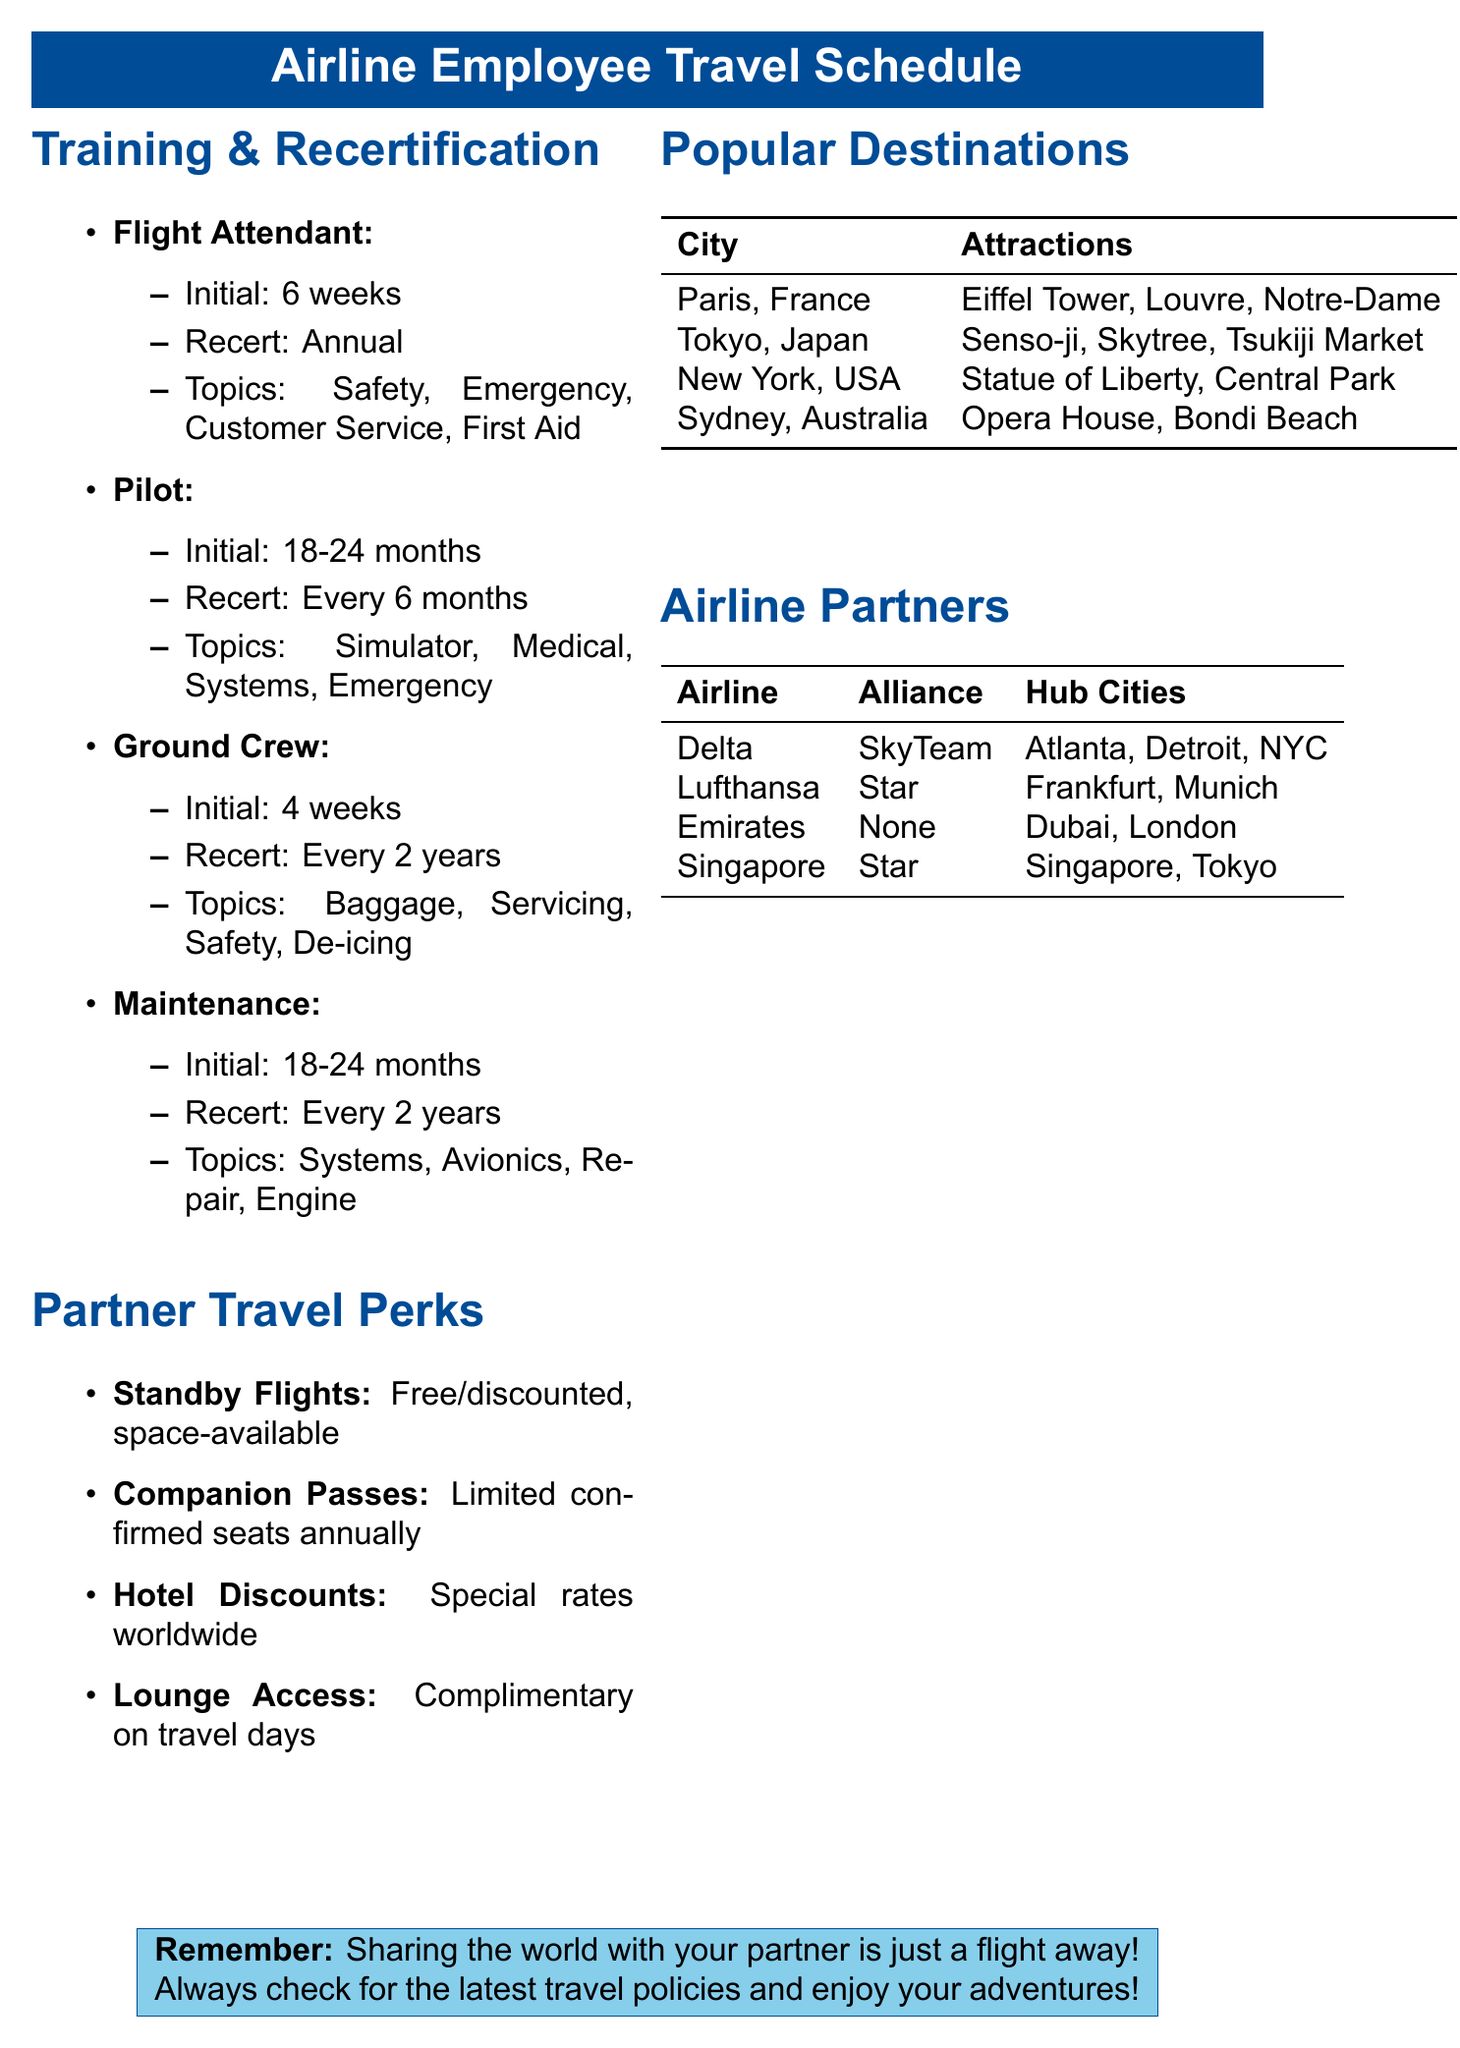What is the initial training duration for Flight Attendants? Initial training for Flight Attendants lasts for 6 weeks.
Answer: 6 weeks How often do Pilots need to recertify? Pilots must recertify every 6 months.
Answer: Every 6 months What topics are included in the Ground Crew training? Ground Crew training topics include Baggage handling, Aircraft servicing, Ramp safety, and De-icing procedures.
Answer: Baggage handling, Aircraft servicing, Ramp safety, De-icing procedures What partner travel perk offers complimentary access? The lounge access perk offers complimentary access.
Answer: Lounge access How many annual confirmed seats are provided through companion passes? The document states there is a limited number of confirmed seats for partners annually through companion passes.
Answer: Limited number Which destination is associated with the Eiffel Tower? The Eiffel Tower is located in Paris, France.
Answer: Paris, France How long does initial training for Maintenance Technicians last? Initial training for Maintenance Technicians lasts between 18 to 24 months.
Answer: 18-24 months What is a restriction for hotel discounts? Hotel discounts require the employee to be traveling with their partner.
Answer: Must be traveling with the employee Which airline is part of the Star Alliance? Lufthansa is part of the Star Alliance.
Answer: Lufthansa How many weeks of initial training does Ground Crew receive? Ground Crew receives 4 weeks of initial training.
Answer: 4 weeks 